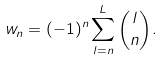Convert formula to latex. <formula><loc_0><loc_0><loc_500><loc_500>w _ { n } = ( - 1 ) ^ { n } \sum _ { l = n } ^ { L } \binom { l } { n } .</formula> 